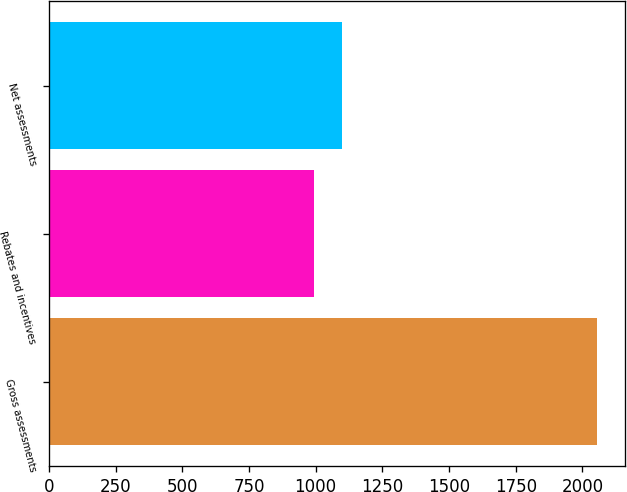Convert chart to OTSL. <chart><loc_0><loc_0><loc_500><loc_500><bar_chart><fcel>Gross assessments<fcel>Rebates and incentives<fcel>Net assessments<nl><fcel>2056<fcel>992<fcel>1098.4<nl></chart> 